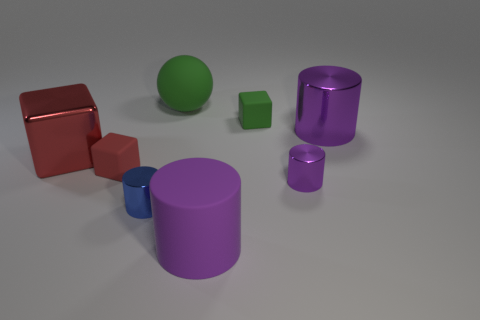Subtract all brown balls. How many purple cylinders are left? 3 Subtract all blue cylinders. How many cylinders are left? 3 Subtract all large purple rubber cylinders. How many cylinders are left? 3 Subtract all yellow cylinders. Subtract all brown spheres. How many cylinders are left? 4 Add 1 big spheres. How many objects exist? 9 Subtract all spheres. How many objects are left? 7 Add 7 tiny green objects. How many tiny green objects are left? 8 Add 7 big purple cylinders. How many big purple cylinders exist? 9 Subtract 0 cyan cylinders. How many objects are left? 8 Subtract all small cyan rubber blocks. Subtract all tiny red blocks. How many objects are left? 7 